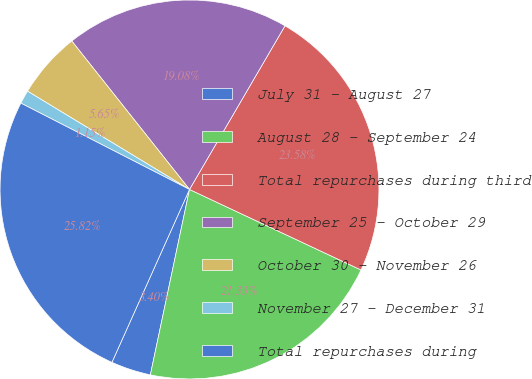Convert chart. <chart><loc_0><loc_0><loc_500><loc_500><pie_chart><fcel>July 31 - August 27<fcel>August 28 - September 24<fcel>Total repurchases during third<fcel>September 25 - October 29<fcel>October 30 - November 26<fcel>November 27 - December 31<fcel>Total repurchases during<nl><fcel>3.4%<fcel>21.33%<fcel>23.58%<fcel>19.08%<fcel>5.65%<fcel>1.15%<fcel>25.82%<nl></chart> 